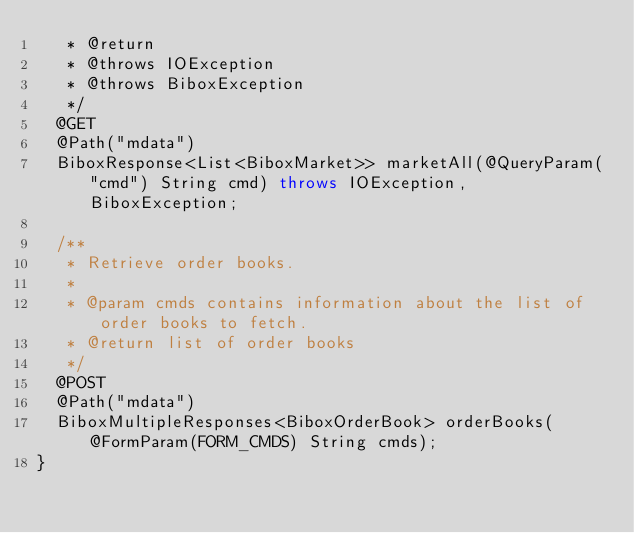Convert code to text. <code><loc_0><loc_0><loc_500><loc_500><_Java_>   * @return
   * @throws IOException
   * @throws BiboxException
   */
  @GET
  @Path("mdata")
  BiboxResponse<List<BiboxMarket>> marketAll(@QueryParam("cmd") String cmd) throws IOException, BiboxException;

  /**
   * Retrieve order books.
   *
   * @param cmds contains information about the list of order books to fetch.
   * @return list of order books
   */
  @POST
  @Path("mdata")
  BiboxMultipleResponses<BiboxOrderBook> orderBooks(@FormParam(FORM_CMDS) String cmds);
}
</code> 